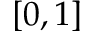<formula> <loc_0><loc_0><loc_500><loc_500>\left [ 0 , 1 \right ]</formula> 